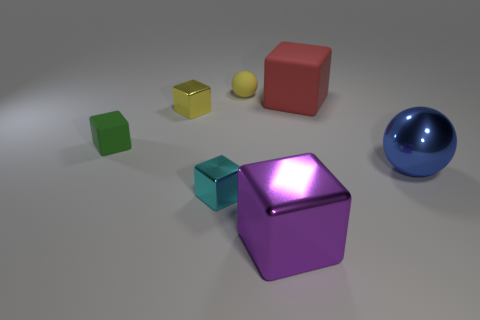What number of other things are the same material as the cyan thing?
Make the answer very short. 3. There is a ball that is on the left side of the purple cube; what material is it?
Offer a terse response. Rubber. There is a small object that is the same color as the small matte sphere; what material is it?
Offer a terse response. Metal. What number of big objects are either red things or cyan metal cylinders?
Keep it short and to the point. 1. The rubber ball is what color?
Offer a terse response. Yellow. There is a shiny cube in front of the tiny cyan thing; is there a tiny green thing to the right of it?
Your answer should be compact. No. Is the number of objects right of the small yellow metal block less than the number of metallic balls?
Offer a very short reply. No. Are the tiny yellow thing that is on the right side of the cyan shiny block and the red block made of the same material?
Your answer should be compact. Yes. What is the color of the other small thing that is the same material as the small cyan object?
Provide a succinct answer. Yellow. Is the number of rubber blocks that are behind the red block less than the number of blue metallic balls behind the blue object?
Ensure brevity in your answer.  No. 